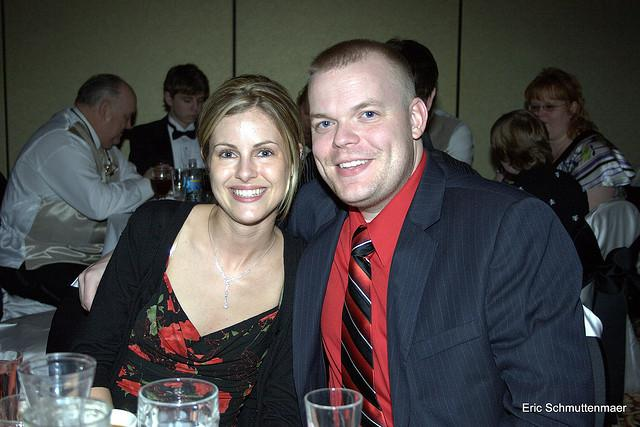Persons here are likely attending what type reception?

Choices:
A) wedding
B) retirement
C) business
D) funeral wedding 